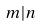Convert formula to latex. <formula><loc_0><loc_0><loc_500><loc_500>m | n</formula> 